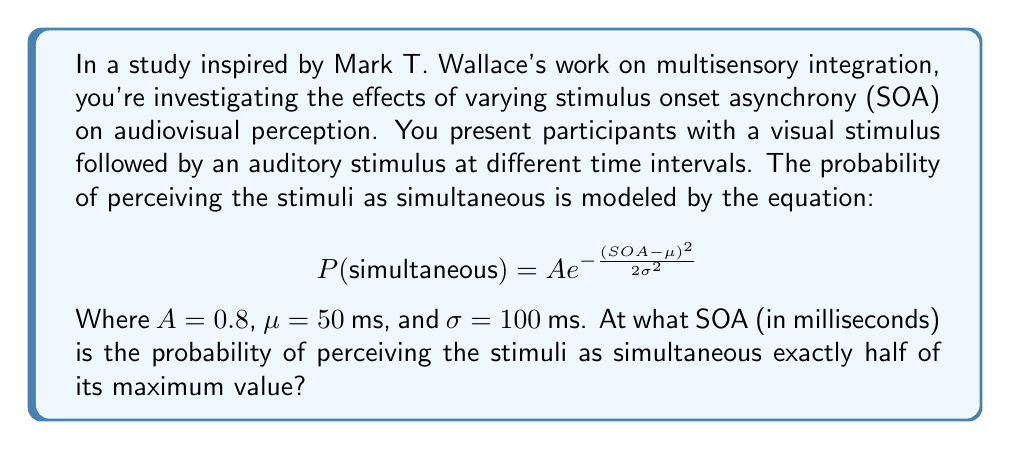Can you answer this question? Let's approach this step-by-step:

1) First, we need to find the maximum value of the probability function. This occurs when $SOA = \mu = 50$ ms. At this point:

   $$P_{max} = Ae^{-\frac{(50-50)^2}{2(100)^2}} = A = 0.8$$

2) We're looking for the SOA where $P(simultaneous) = 0.5P_{max} = 0.5 * 0.8 = 0.4$

3) Now, we can set up our equation:

   $$0.4 = 0.8e^{-\frac{(SOA-50)^2}{2(100)^2}}$$

4) Simplify:

   $$0.5 = e^{-\frac{(SOA-50)^2}{20000}}$$

5) Take the natural log of both sides:

   $$\ln(0.5) = -\frac{(SOA-50)^2}{20000}$$

6) Multiply both sides by -20000:

   $$-20000\ln(0.5) = (SOA-50)^2$$

7) Take the square root of both sides:

   $$\sqrt{-20000\ln(0.5)} = |SOA-50|$$

8) Calculate the value:

   $$\sqrt{-20000\ln(0.5)} \approx 117.41$$

9) Solve for SOA:

   $SOA - 50 = \pm 117.41$
   $SOA = 50 \pm 117.41$

10) This gives us two solutions: $SOA \approx 167.41$ ms or $SOA \approx -67.41$ ms

11) Since SOA is typically positive in such experiments, we take the positive solution.
Answer: 167.41 ms 